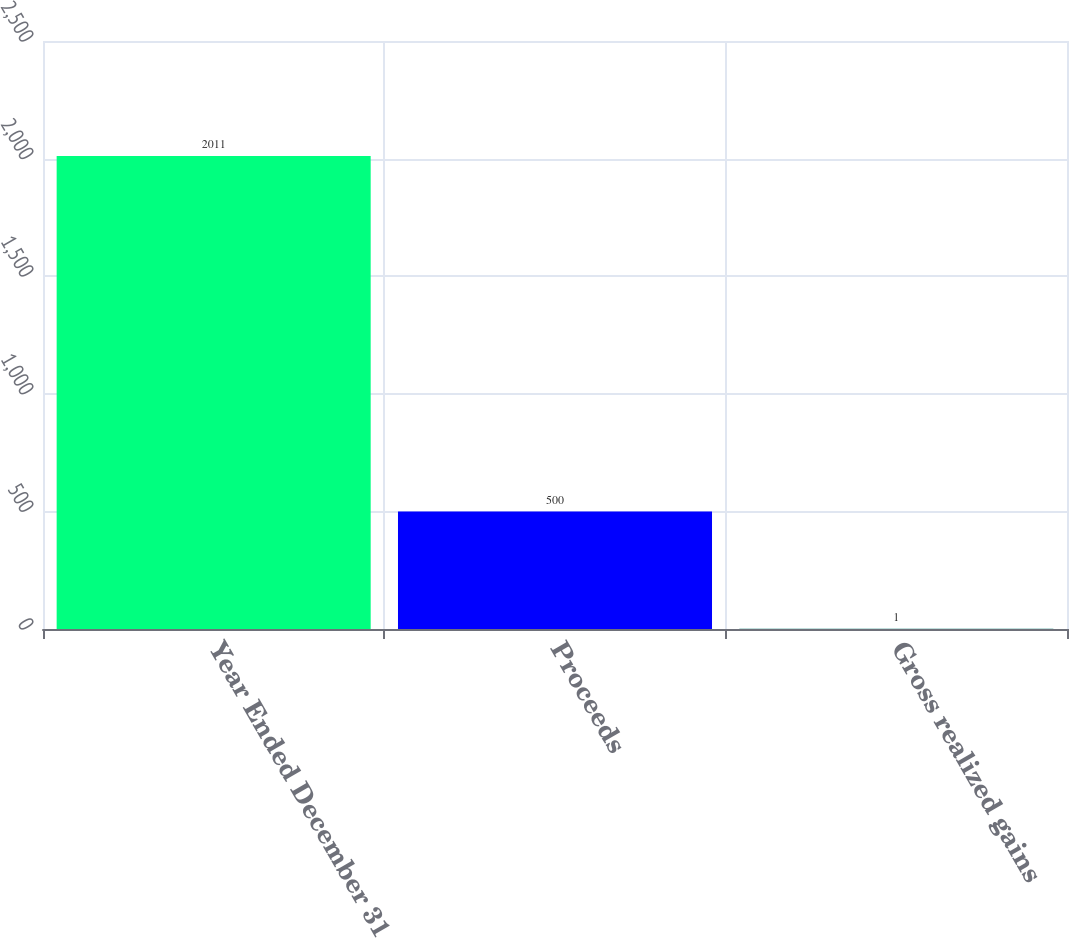Convert chart. <chart><loc_0><loc_0><loc_500><loc_500><bar_chart><fcel>Year Ended December 31<fcel>Proceeds<fcel>Gross realized gains<nl><fcel>2011<fcel>500<fcel>1<nl></chart> 